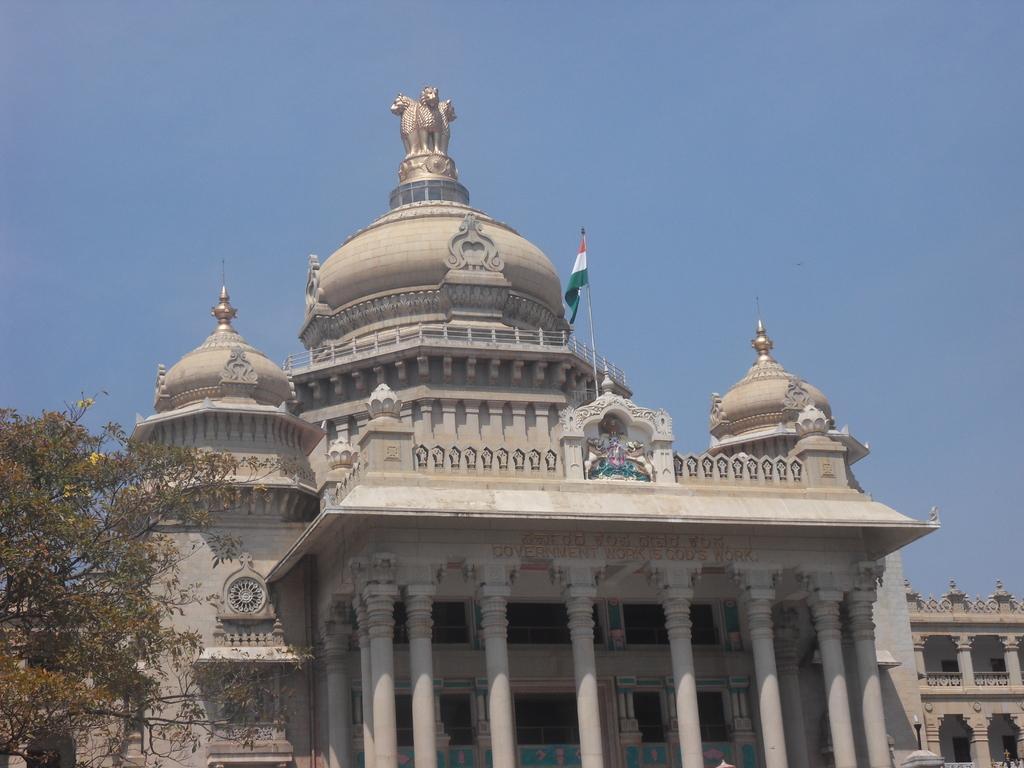Describe this image in one or two sentences. Sky is in blue color. Above this building there is a flag. Here we can see pillars and tree. 